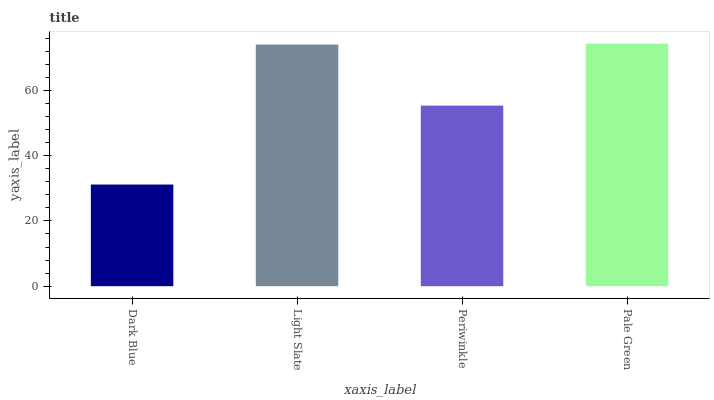Is Dark Blue the minimum?
Answer yes or no. Yes. Is Pale Green the maximum?
Answer yes or no. Yes. Is Light Slate the minimum?
Answer yes or no. No. Is Light Slate the maximum?
Answer yes or no. No. Is Light Slate greater than Dark Blue?
Answer yes or no. Yes. Is Dark Blue less than Light Slate?
Answer yes or no. Yes. Is Dark Blue greater than Light Slate?
Answer yes or no. No. Is Light Slate less than Dark Blue?
Answer yes or no. No. Is Light Slate the high median?
Answer yes or no. Yes. Is Periwinkle the low median?
Answer yes or no. Yes. Is Periwinkle the high median?
Answer yes or no. No. Is Light Slate the low median?
Answer yes or no. No. 